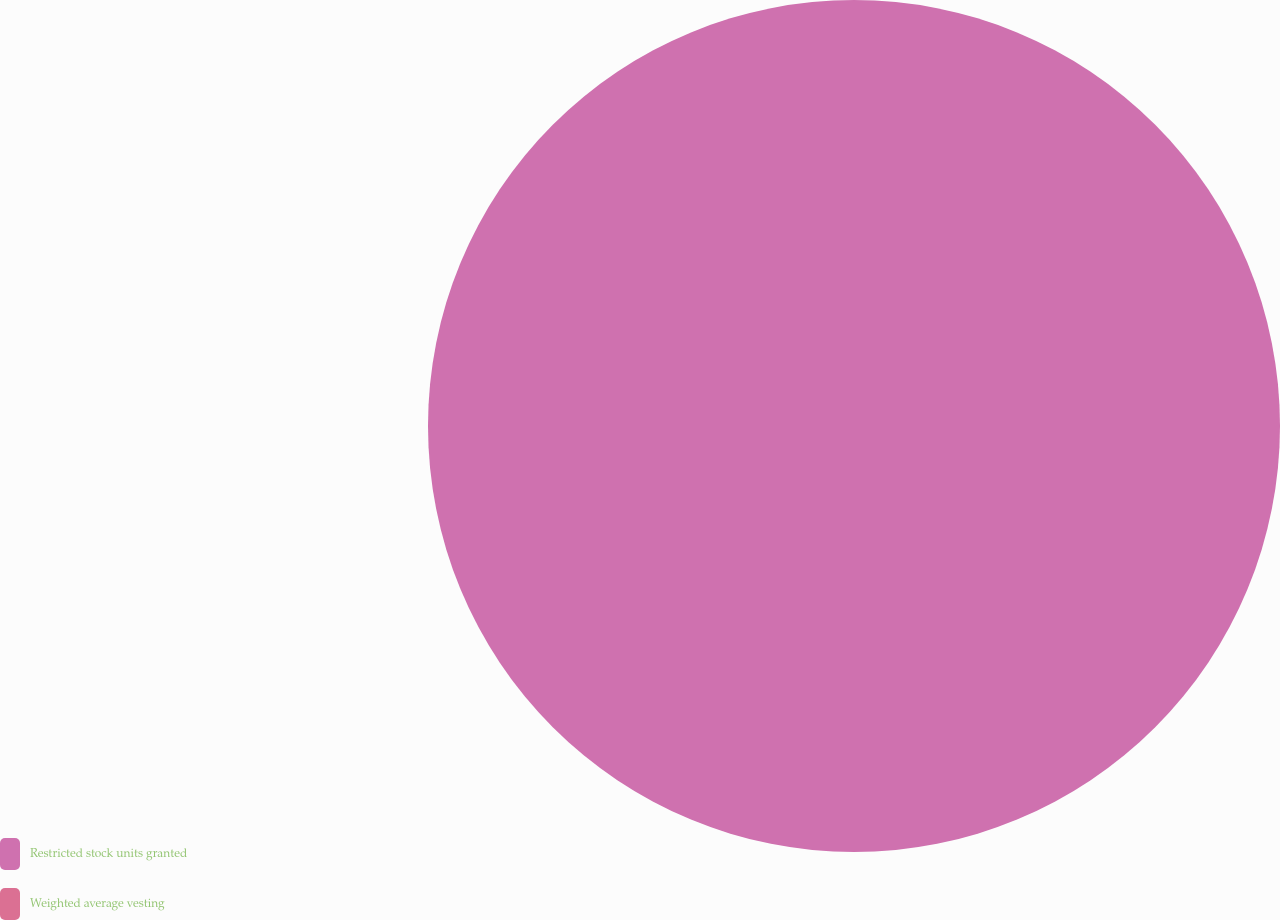Convert chart. <chart><loc_0><loc_0><loc_500><loc_500><pie_chart><fcel>Restricted stock units granted<fcel>Weighted average vesting<nl><fcel>100.0%<fcel>0.0%<nl></chart> 